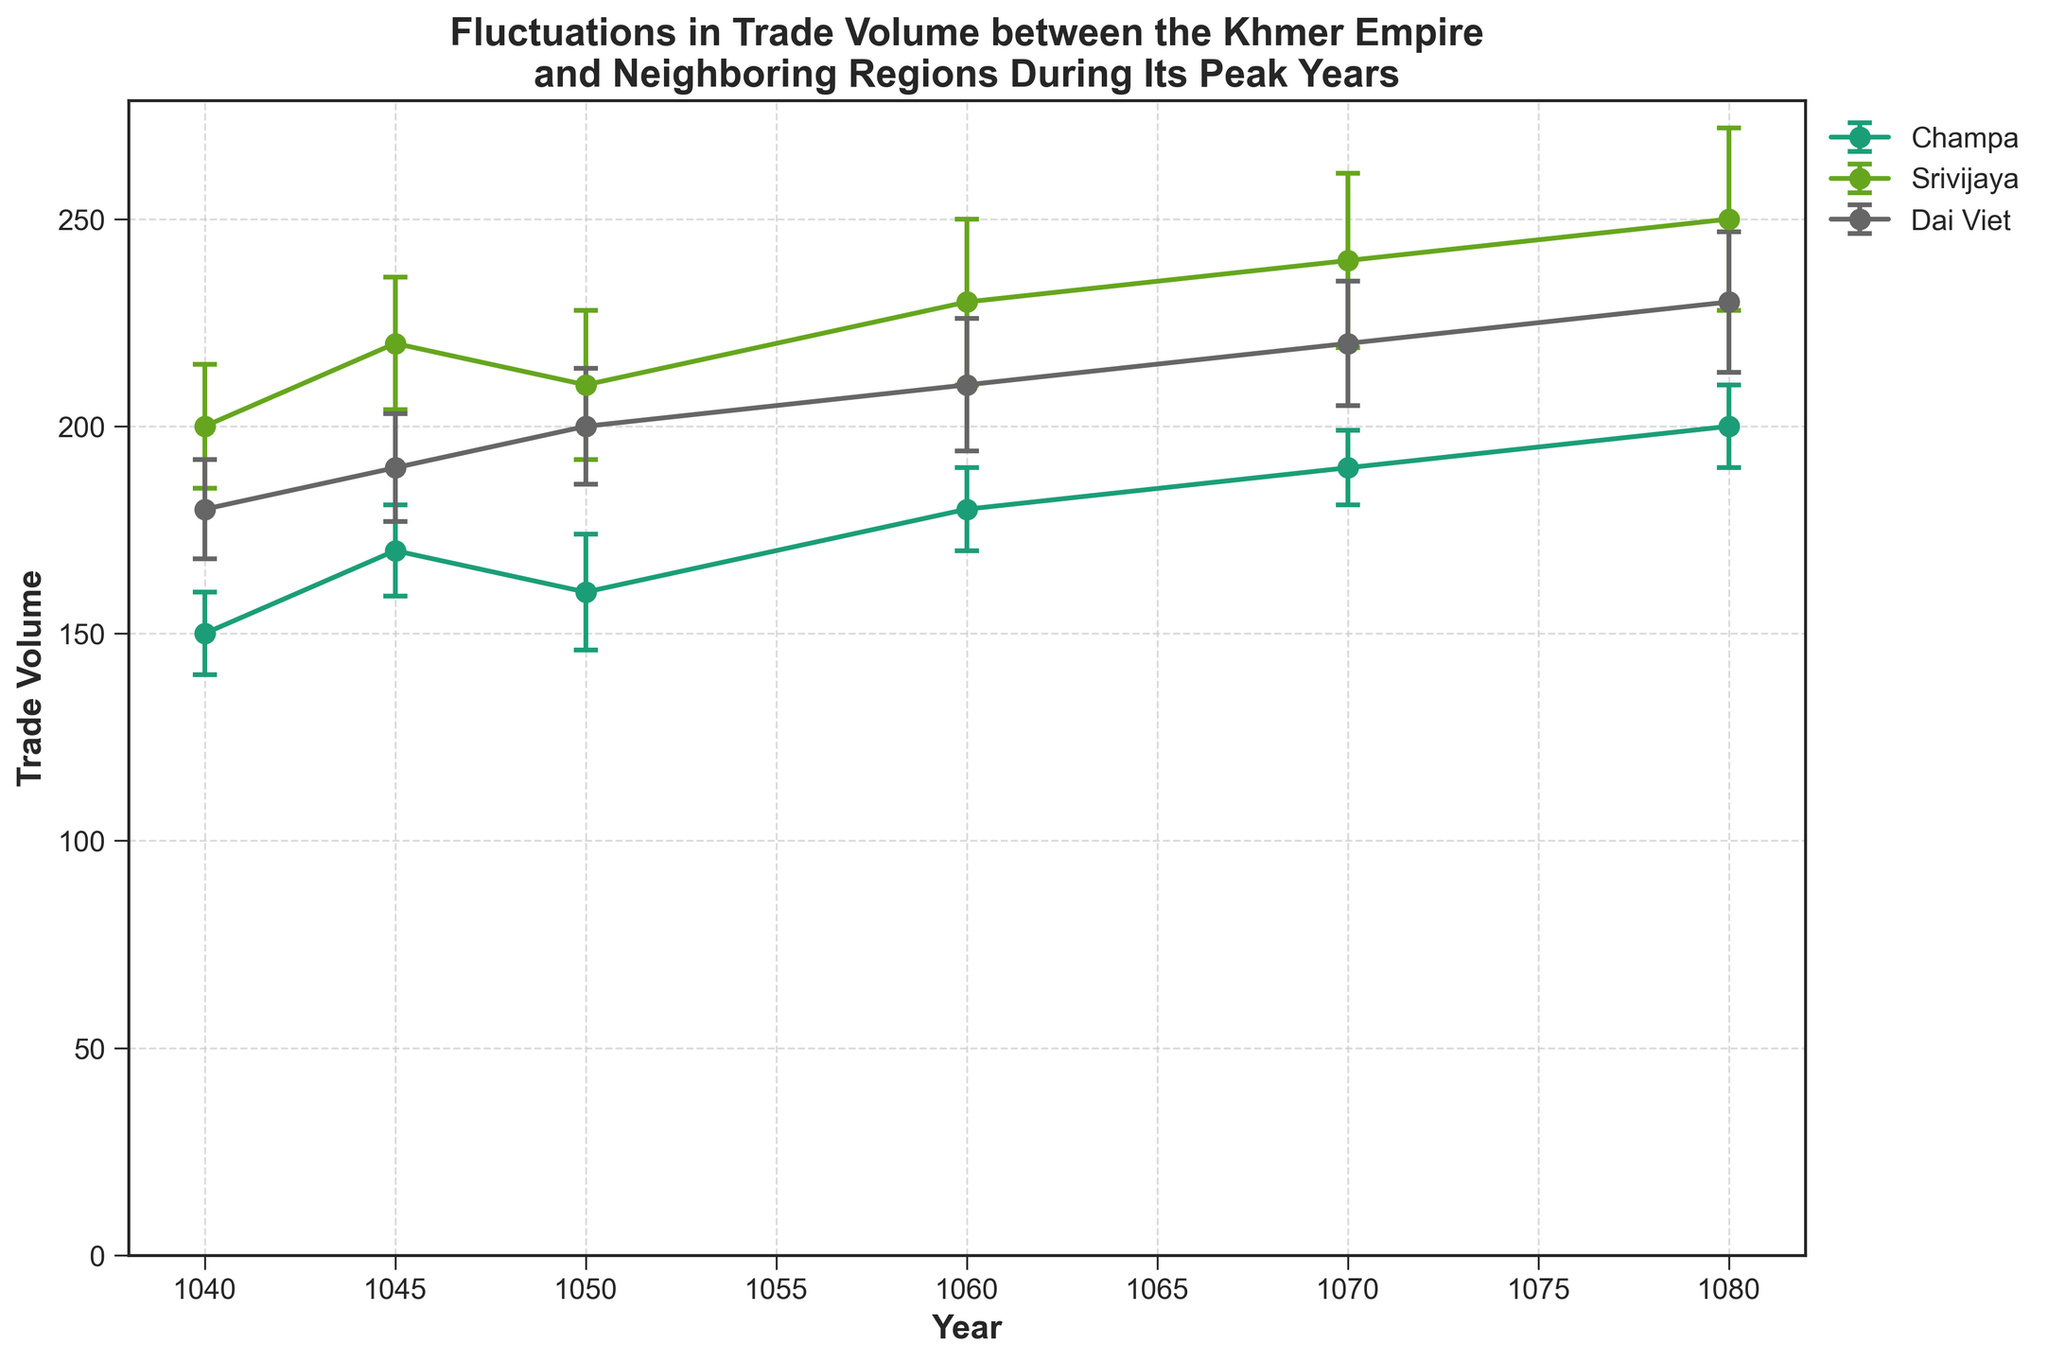What is the title of the plot? The title is often placed at the top of the plot. The text in that position is "Fluctuations in Trade Volume between the Khmer Empire and Neighboring Regions During Its Peak Years."
Answer: Fluctuations in Trade Volume between the Khmer Empire and Neighboring Regions During Its Peak Years Which region showed the lowest trade volume in 1040? Look at the data points for 1040 and compare the trade volumes for Champa, Srivijaya, and Dai Viet. The lowest value among them is for Champa, which is 150.
Answer: Champa How did the trade volume of Srivijaya change between 1040 and 1080? Identify the trade volume of Srivijaya in 1040 (200) and compare with its trade volume in 1080 (250). The change is 250 - 200 = 50 units.
Answer: Increased by 50 units What is the standard error for Dai Viet's trade volume in 1060? Locate the year 1060 for Dai Viet and identify the associated standard error value in the plot, which is shown as 16.
Answer: 16 Which year did Champa's trade volume reach 200 units? Look across the line representing Champa and find the data point that reaches 200 units, corresponding to the year 1080.
Answer: 1080 What are the respective increases in trade volume for Champa and Dai Viet between 1050 and 1070? Determine the trade volumes for Champa in 1050 (160) and 1070 (190), and for Dai Viet in 1050 (200) and 1070 (220). Calculate the differences for both: Champa (190 - 160 = 30 units), Dai Viet (220 - 200 = 20 units).
Answer: Champa: 30 units, Dai Viet: 20 units Did any region's trade volume show a decline between 1045 and 1050? Compare the trade volumes for each region between 1045 and 1050: Champa (170 to 160, decline of 10 units), Srivijaya (220 to 210, decline of 10 units), Dai Viet (190 to 200, increase of 10 units). Champa and Srivijaya both experienced declines.
Answer: Yes, Champa and Srivijaya Which region had the highest trade volume in the year 1060? Look at the trade volumes for all regions in the year 1060: Champa (180), Srivijaya (230), Dai Viet (210). The highest among these is Srivijaya.
Answer: Srivijaya Which region demonstrated the most stable trade volume based on the smallest standard errors reflected in the plot? Compare the error bars of each region across all years. Champa has relatively smaller and more consistent error bars compared to Srivijaya and Dai Viet, indicating it had the most stable trade volume.
Answer: Champa 